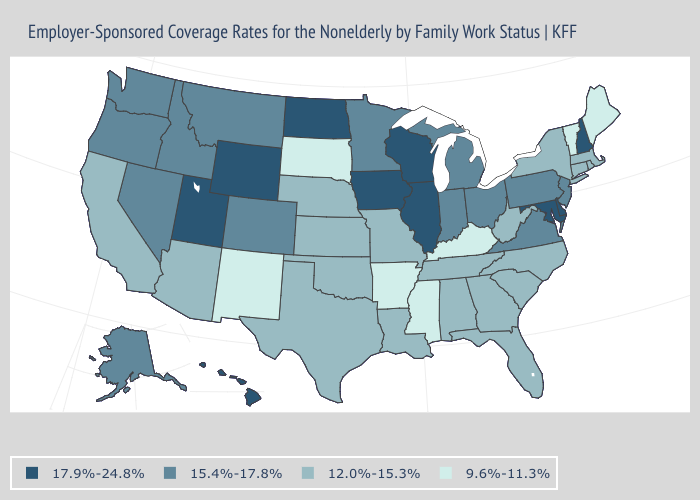Which states have the lowest value in the MidWest?
Concise answer only. South Dakota. Does Connecticut have a higher value than Ohio?
Be succinct. No. Among the states that border Nebraska , which have the highest value?
Be succinct. Iowa, Wyoming. What is the highest value in the USA?
Be succinct. 17.9%-24.8%. Name the states that have a value in the range 12.0%-15.3%?
Be succinct. Alabama, Arizona, California, Connecticut, Florida, Georgia, Kansas, Louisiana, Massachusetts, Missouri, Nebraska, New York, North Carolina, Oklahoma, Rhode Island, South Carolina, Tennessee, Texas, West Virginia. Name the states that have a value in the range 15.4%-17.8%?
Concise answer only. Alaska, Colorado, Idaho, Indiana, Michigan, Minnesota, Montana, Nevada, New Jersey, Ohio, Oregon, Pennsylvania, Virginia, Washington. What is the lowest value in the South?
Concise answer only. 9.6%-11.3%. Among the states that border New York , which have the lowest value?
Quick response, please. Vermont. What is the value of New Hampshire?
Quick response, please. 17.9%-24.8%. What is the value of Missouri?
Write a very short answer. 12.0%-15.3%. Among the states that border Mississippi , which have the lowest value?
Short answer required. Arkansas. What is the value of Connecticut?
Keep it brief. 12.0%-15.3%. Name the states that have a value in the range 12.0%-15.3%?
Write a very short answer. Alabama, Arizona, California, Connecticut, Florida, Georgia, Kansas, Louisiana, Massachusetts, Missouri, Nebraska, New York, North Carolina, Oklahoma, Rhode Island, South Carolina, Tennessee, Texas, West Virginia. What is the lowest value in the West?
Write a very short answer. 9.6%-11.3%. Among the states that border Idaho , which have the lowest value?
Quick response, please. Montana, Nevada, Oregon, Washington. 